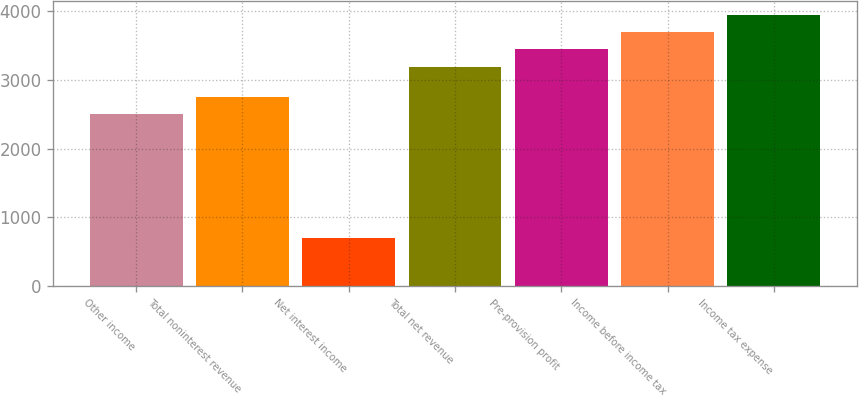<chart> <loc_0><loc_0><loc_500><loc_500><bar_chart><fcel>Other income<fcel>Total noninterest revenue<fcel>Net interest income<fcel>Total net revenue<fcel>Pre-provision profit<fcel>Income before income tax<fcel>Income tax expense<nl><fcel>2495<fcel>2744.5<fcel>697<fcel>3192<fcel>3441.5<fcel>3691<fcel>3940.5<nl></chart> 